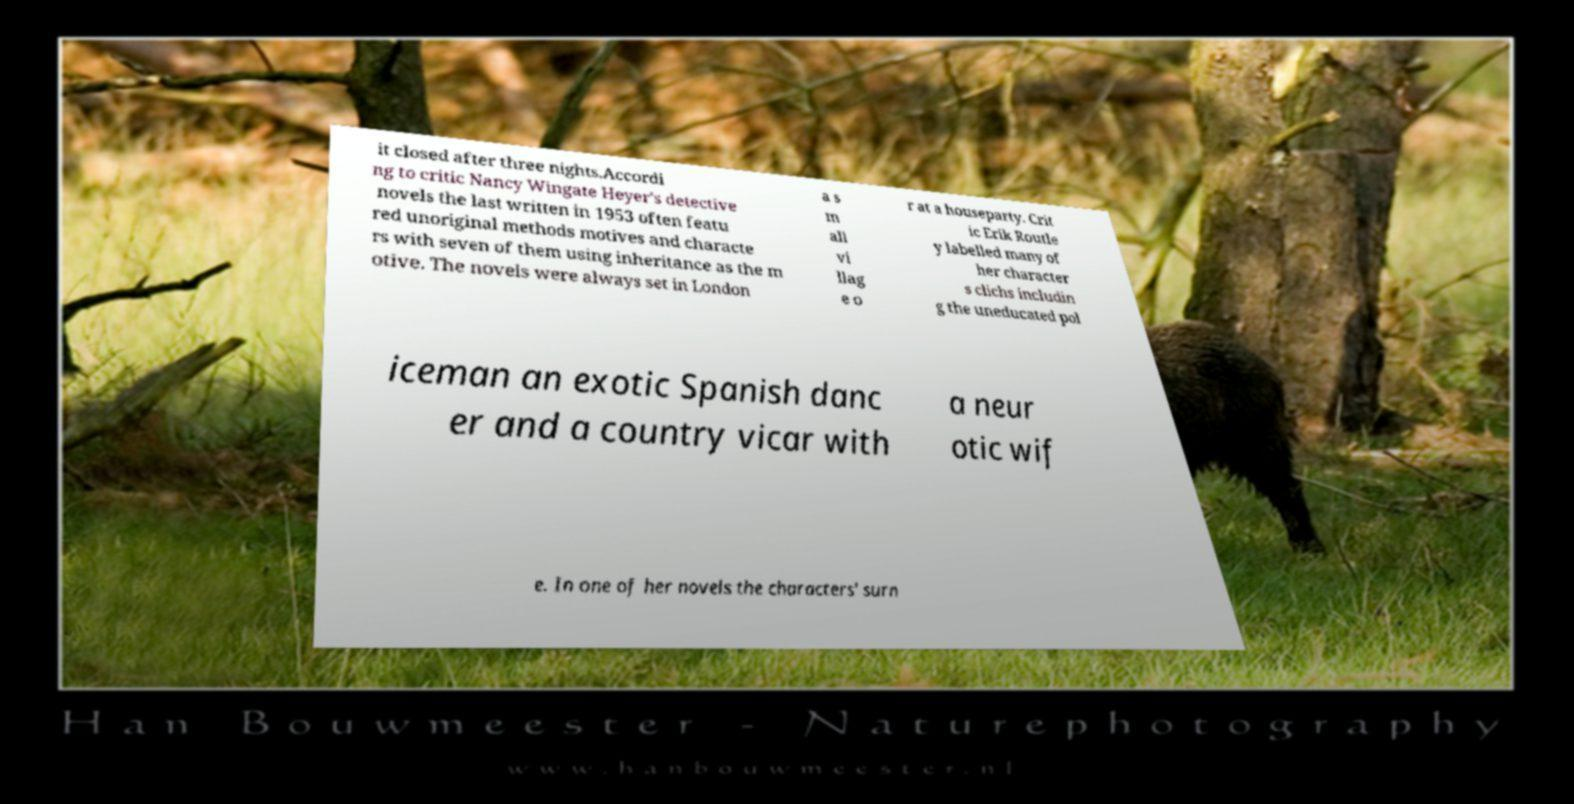Please read and relay the text visible in this image. What does it say? it closed after three nights.Accordi ng to critic Nancy Wingate Heyer's detective novels the last written in 1953 often featu red unoriginal methods motives and characte rs with seven of them using inheritance as the m otive. The novels were always set in London a s m all vi llag e o r at a houseparty. Crit ic Erik Routle y labelled many of her character s clichs includin g the uneducated pol iceman an exotic Spanish danc er and a country vicar with a neur otic wif e. In one of her novels the characters' surn 